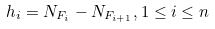Convert formula to latex. <formula><loc_0><loc_0><loc_500><loc_500>h _ { i } = N _ { F _ { i } } - N _ { F _ { i + 1 } } , 1 \leq i \leq n</formula> 